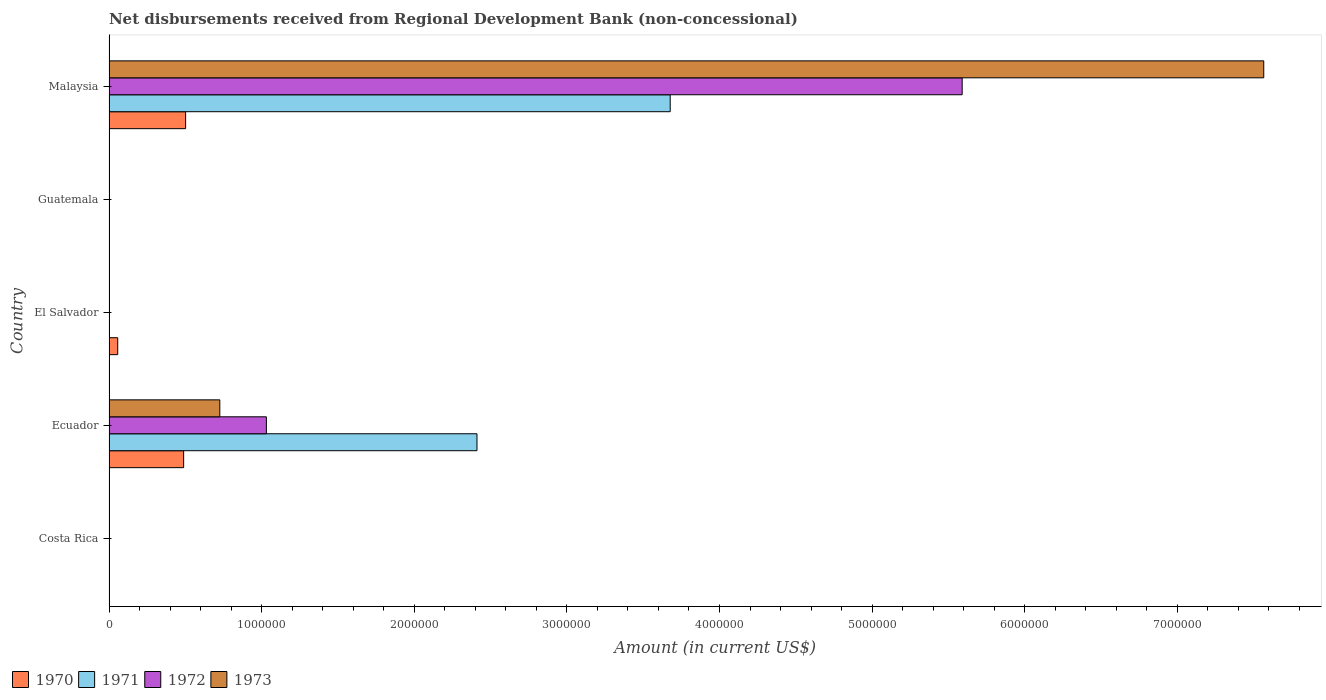How many different coloured bars are there?
Provide a short and direct response. 4. Are the number of bars on each tick of the Y-axis equal?
Offer a terse response. No. How many bars are there on the 4th tick from the bottom?
Ensure brevity in your answer.  0. What is the label of the 1st group of bars from the top?
Provide a succinct answer. Malaysia. Across all countries, what is the maximum amount of disbursements received from Regional Development Bank in 1970?
Provide a short and direct response. 5.02e+05. In which country was the amount of disbursements received from Regional Development Bank in 1971 maximum?
Offer a very short reply. Malaysia. What is the total amount of disbursements received from Regional Development Bank in 1972 in the graph?
Offer a terse response. 6.62e+06. What is the difference between the amount of disbursements received from Regional Development Bank in 1973 in Ecuador and that in Malaysia?
Offer a terse response. -6.84e+06. What is the average amount of disbursements received from Regional Development Bank in 1970 per country?
Your response must be concise. 2.10e+05. What is the difference between the amount of disbursements received from Regional Development Bank in 1970 and amount of disbursements received from Regional Development Bank in 1971 in Ecuador?
Keep it short and to the point. -1.92e+06. What is the ratio of the amount of disbursements received from Regional Development Bank in 1973 in Ecuador to that in Malaysia?
Your answer should be compact. 0.1. Is the difference between the amount of disbursements received from Regional Development Bank in 1970 in Ecuador and Malaysia greater than the difference between the amount of disbursements received from Regional Development Bank in 1971 in Ecuador and Malaysia?
Your response must be concise. Yes. What is the difference between the highest and the second highest amount of disbursements received from Regional Development Bank in 1970?
Make the answer very short. 1.30e+04. What is the difference between the highest and the lowest amount of disbursements received from Regional Development Bank in 1972?
Offer a terse response. 5.59e+06. In how many countries, is the amount of disbursements received from Regional Development Bank in 1973 greater than the average amount of disbursements received from Regional Development Bank in 1973 taken over all countries?
Give a very brief answer. 1. How many bars are there?
Your answer should be very brief. 9. How many countries are there in the graph?
Provide a short and direct response. 5. Are the values on the major ticks of X-axis written in scientific E-notation?
Provide a succinct answer. No. Does the graph contain any zero values?
Keep it short and to the point. Yes. How are the legend labels stacked?
Your answer should be very brief. Horizontal. What is the title of the graph?
Give a very brief answer. Net disbursements received from Regional Development Bank (non-concessional). What is the label or title of the Y-axis?
Your response must be concise. Country. What is the Amount (in current US$) of 1970 in Costa Rica?
Give a very brief answer. 0. What is the Amount (in current US$) of 1972 in Costa Rica?
Make the answer very short. 0. What is the Amount (in current US$) of 1970 in Ecuador?
Provide a succinct answer. 4.89e+05. What is the Amount (in current US$) of 1971 in Ecuador?
Make the answer very short. 2.41e+06. What is the Amount (in current US$) in 1972 in Ecuador?
Your answer should be very brief. 1.03e+06. What is the Amount (in current US$) of 1973 in Ecuador?
Your answer should be compact. 7.26e+05. What is the Amount (in current US$) in 1970 in El Salvador?
Ensure brevity in your answer.  5.70e+04. What is the Amount (in current US$) of 1972 in El Salvador?
Your answer should be very brief. 0. What is the Amount (in current US$) of 1970 in Guatemala?
Provide a short and direct response. 0. What is the Amount (in current US$) of 1971 in Guatemala?
Your response must be concise. 0. What is the Amount (in current US$) in 1973 in Guatemala?
Provide a succinct answer. 0. What is the Amount (in current US$) of 1970 in Malaysia?
Offer a very short reply. 5.02e+05. What is the Amount (in current US$) of 1971 in Malaysia?
Make the answer very short. 3.68e+06. What is the Amount (in current US$) of 1972 in Malaysia?
Keep it short and to the point. 5.59e+06. What is the Amount (in current US$) of 1973 in Malaysia?
Give a very brief answer. 7.57e+06. Across all countries, what is the maximum Amount (in current US$) of 1970?
Offer a terse response. 5.02e+05. Across all countries, what is the maximum Amount (in current US$) of 1971?
Give a very brief answer. 3.68e+06. Across all countries, what is the maximum Amount (in current US$) of 1972?
Give a very brief answer. 5.59e+06. Across all countries, what is the maximum Amount (in current US$) in 1973?
Give a very brief answer. 7.57e+06. What is the total Amount (in current US$) of 1970 in the graph?
Offer a terse response. 1.05e+06. What is the total Amount (in current US$) of 1971 in the graph?
Provide a succinct answer. 6.09e+06. What is the total Amount (in current US$) of 1972 in the graph?
Your answer should be very brief. 6.62e+06. What is the total Amount (in current US$) in 1973 in the graph?
Offer a very short reply. 8.29e+06. What is the difference between the Amount (in current US$) of 1970 in Ecuador and that in El Salvador?
Your answer should be very brief. 4.32e+05. What is the difference between the Amount (in current US$) of 1970 in Ecuador and that in Malaysia?
Keep it short and to the point. -1.30e+04. What is the difference between the Amount (in current US$) in 1971 in Ecuador and that in Malaysia?
Ensure brevity in your answer.  -1.27e+06. What is the difference between the Amount (in current US$) of 1972 in Ecuador and that in Malaysia?
Your response must be concise. -4.56e+06. What is the difference between the Amount (in current US$) in 1973 in Ecuador and that in Malaysia?
Offer a terse response. -6.84e+06. What is the difference between the Amount (in current US$) of 1970 in El Salvador and that in Malaysia?
Your answer should be very brief. -4.45e+05. What is the difference between the Amount (in current US$) in 1970 in Ecuador and the Amount (in current US$) in 1971 in Malaysia?
Ensure brevity in your answer.  -3.19e+06. What is the difference between the Amount (in current US$) in 1970 in Ecuador and the Amount (in current US$) in 1972 in Malaysia?
Provide a short and direct response. -5.10e+06. What is the difference between the Amount (in current US$) in 1970 in Ecuador and the Amount (in current US$) in 1973 in Malaysia?
Provide a short and direct response. -7.08e+06. What is the difference between the Amount (in current US$) of 1971 in Ecuador and the Amount (in current US$) of 1972 in Malaysia?
Your response must be concise. -3.18e+06. What is the difference between the Amount (in current US$) in 1971 in Ecuador and the Amount (in current US$) in 1973 in Malaysia?
Ensure brevity in your answer.  -5.16e+06. What is the difference between the Amount (in current US$) in 1972 in Ecuador and the Amount (in current US$) in 1973 in Malaysia?
Give a very brief answer. -6.54e+06. What is the difference between the Amount (in current US$) in 1970 in El Salvador and the Amount (in current US$) in 1971 in Malaysia?
Your answer should be very brief. -3.62e+06. What is the difference between the Amount (in current US$) in 1970 in El Salvador and the Amount (in current US$) in 1972 in Malaysia?
Make the answer very short. -5.53e+06. What is the difference between the Amount (in current US$) in 1970 in El Salvador and the Amount (in current US$) in 1973 in Malaysia?
Provide a succinct answer. -7.51e+06. What is the average Amount (in current US$) in 1970 per country?
Your response must be concise. 2.10e+05. What is the average Amount (in current US$) in 1971 per country?
Offer a terse response. 1.22e+06. What is the average Amount (in current US$) of 1972 per country?
Your answer should be very brief. 1.32e+06. What is the average Amount (in current US$) in 1973 per country?
Provide a succinct answer. 1.66e+06. What is the difference between the Amount (in current US$) in 1970 and Amount (in current US$) in 1971 in Ecuador?
Your answer should be very brief. -1.92e+06. What is the difference between the Amount (in current US$) in 1970 and Amount (in current US$) in 1972 in Ecuador?
Offer a very short reply. -5.42e+05. What is the difference between the Amount (in current US$) of 1970 and Amount (in current US$) of 1973 in Ecuador?
Your response must be concise. -2.37e+05. What is the difference between the Amount (in current US$) of 1971 and Amount (in current US$) of 1972 in Ecuador?
Give a very brief answer. 1.38e+06. What is the difference between the Amount (in current US$) of 1971 and Amount (in current US$) of 1973 in Ecuador?
Your answer should be very brief. 1.68e+06. What is the difference between the Amount (in current US$) in 1972 and Amount (in current US$) in 1973 in Ecuador?
Provide a succinct answer. 3.05e+05. What is the difference between the Amount (in current US$) of 1970 and Amount (in current US$) of 1971 in Malaysia?
Provide a succinct answer. -3.18e+06. What is the difference between the Amount (in current US$) in 1970 and Amount (in current US$) in 1972 in Malaysia?
Provide a succinct answer. -5.09e+06. What is the difference between the Amount (in current US$) in 1970 and Amount (in current US$) in 1973 in Malaysia?
Offer a very short reply. -7.06e+06. What is the difference between the Amount (in current US$) in 1971 and Amount (in current US$) in 1972 in Malaysia?
Your answer should be compact. -1.91e+06. What is the difference between the Amount (in current US$) in 1971 and Amount (in current US$) in 1973 in Malaysia?
Keep it short and to the point. -3.89e+06. What is the difference between the Amount (in current US$) in 1972 and Amount (in current US$) in 1973 in Malaysia?
Your answer should be compact. -1.98e+06. What is the ratio of the Amount (in current US$) of 1970 in Ecuador to that in El Salvador?
Provide a short and direct response. 8.58. What is the ratio of the Amount (in current US$) in 1970 in Ecuador to that in Malaysia?
Your response must be concise. 0.97. What is the ratio of the Amount (in current US$) in 1971 in Ecuador to that in Malaysia?
Provide a succinct answer. 0.66. What is the ratio of the Amount (in current US$) in 1972 in Ecuador to that in Malaysia?
Provide a short and direct response. 0.18. What is the ratio of the Amount (in current US$) in 1973 in Ecuador to that in Malaysia?
Give a very brief answer. 0.1. What is the ratio of the Amount (in current US$) in 1970 in El Salvador to that in Malaysia?
Offer a terse response. 0.11. What is the difference between the highest and the second highest Amount (in current US$) in 1970?
Keep it short and to the point. 1.30e+04. What is the difference between the highest and the lowest Amount (in current US$) in 1970?
Your answer should be very brief. 5.02e+05. What is the difference between the highest and the lowest Amount (in current US$) in 1971?
Make the answer very short. 3.68e+06. What is the difference between the highest and the lowest Amount (in current US$) of 1972?
Offer a terse response. 5.59e+06. What is the difference between the highest and the lowest Amount (in current US$) in 1973?
Provide a short and direct response. 7.57e+06. 